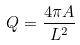Convert formula to latex. <formula><loc_0><loc_0><loc_500><loc_500>Q = \frac { 4 \pi A } { L ^ { 2 } }</formula> 